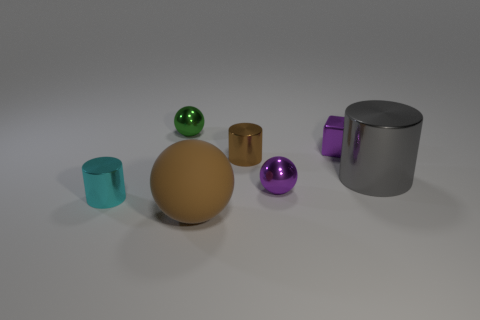Subtract all metal balls. How many balls are left? 1 Add 3 big cyan metallic blocks. How many objects exist? 10 Subtract all green spheres. How many spheres are left? 2 Subtract all cubes. How many objects are left? 6 Subtract all red cubes. Subtract all brown cylinders. How many cubes are left? 1 Subtract all blue cylinders. How many red blocks are left? 0 Add 3 big gray cylinders. How many big gray cylinders are left? 4 Add 6 tiny cyan shiny cylinders. How many tiny cyan shiny cylinders exist? 7 Subtract 1 cyan cylinders. How many objects are left? 6 Subtract 1 balls. How many balls are left? 2 